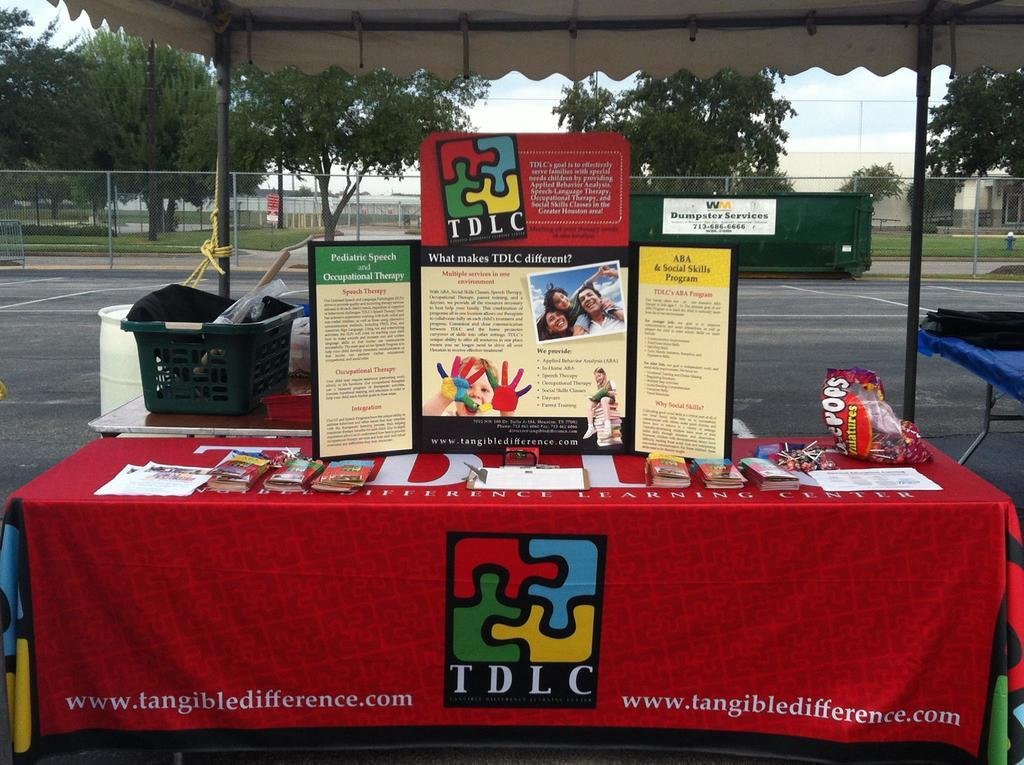<image>
Offer a succinct explanation of the picture presented. A booth set up outside by the company TDLC. 